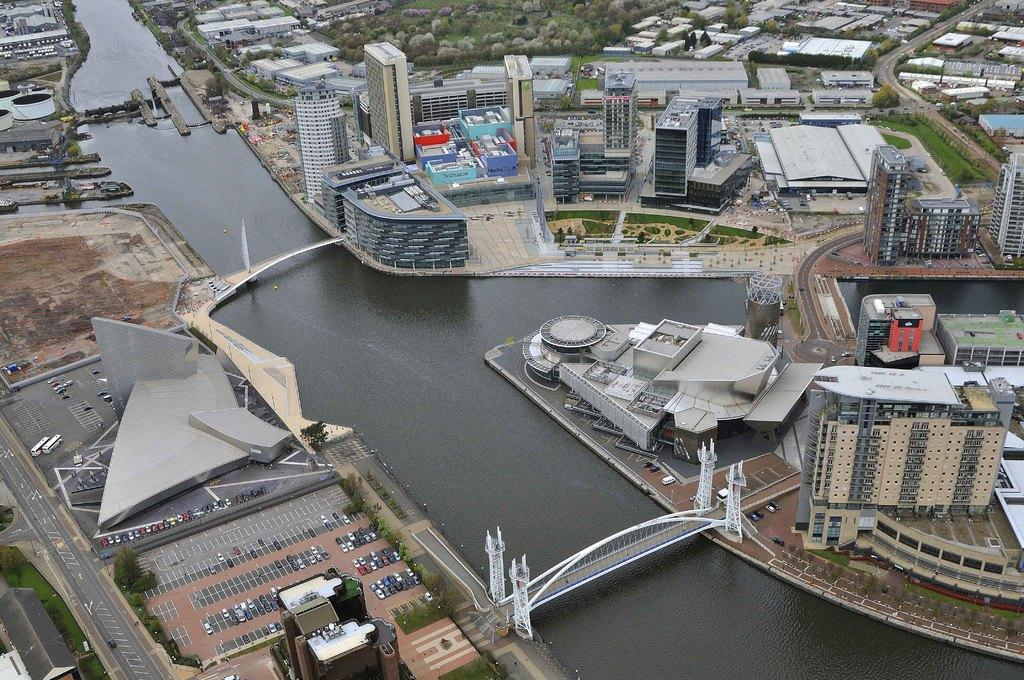What type of structures can be seen in the image? There are buildings in the image. What natural element is visible in the image? There is water visible in the image. What type of vegetation is present in the image? There are plants in the image. What is covering the ground in the image? There is grass on the ground in the image. What type of man-made structures connect different areas in the image? There are bridges in the image. What type of transportation is present in the image? There are vehicles in the image. What type of pollution can be seen in the image? There is no mention of pollution in the image; it only shows buildings, water, plants, grass, bridges, and vehicles. Which direction is the desk facing in the image? There is no desk present in the image. 